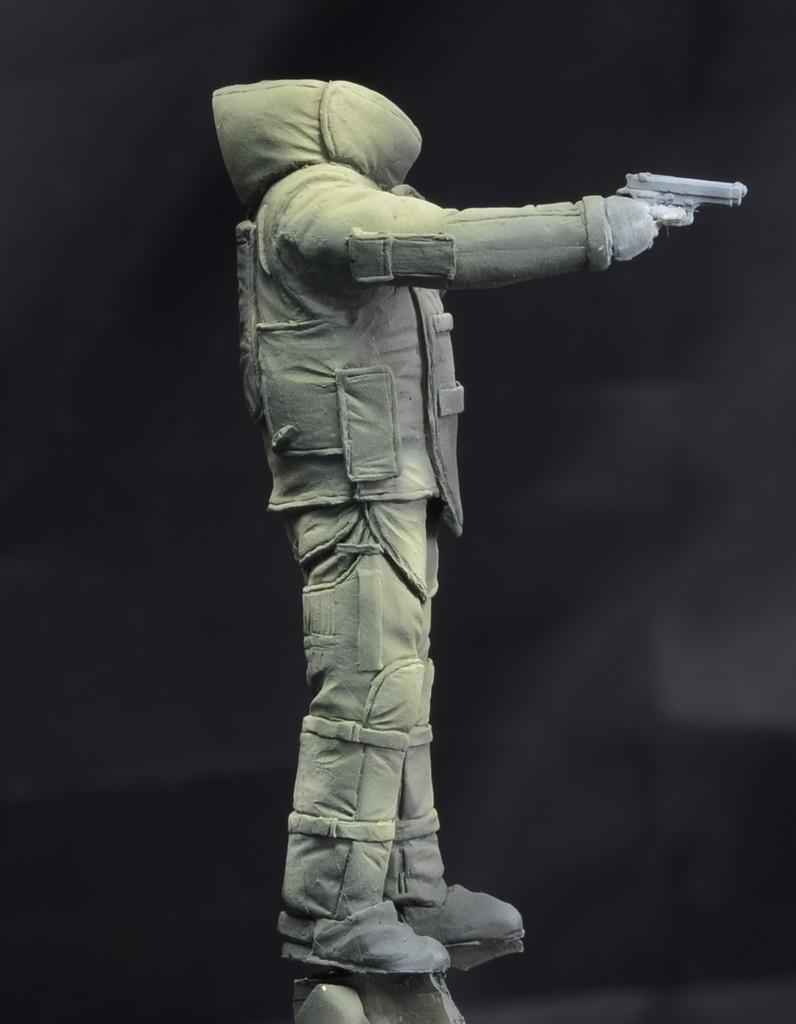What is the main subject of the image? There is a costume in the image. Can you describe the background of the image? The background of the image is blurred. How many hens are present in the image? There are no hens present in the image; it features a costume and a blurred background. What type of paste is being used by the person wearing the costume in the image? There is no paste or any indication of its use in the image. 